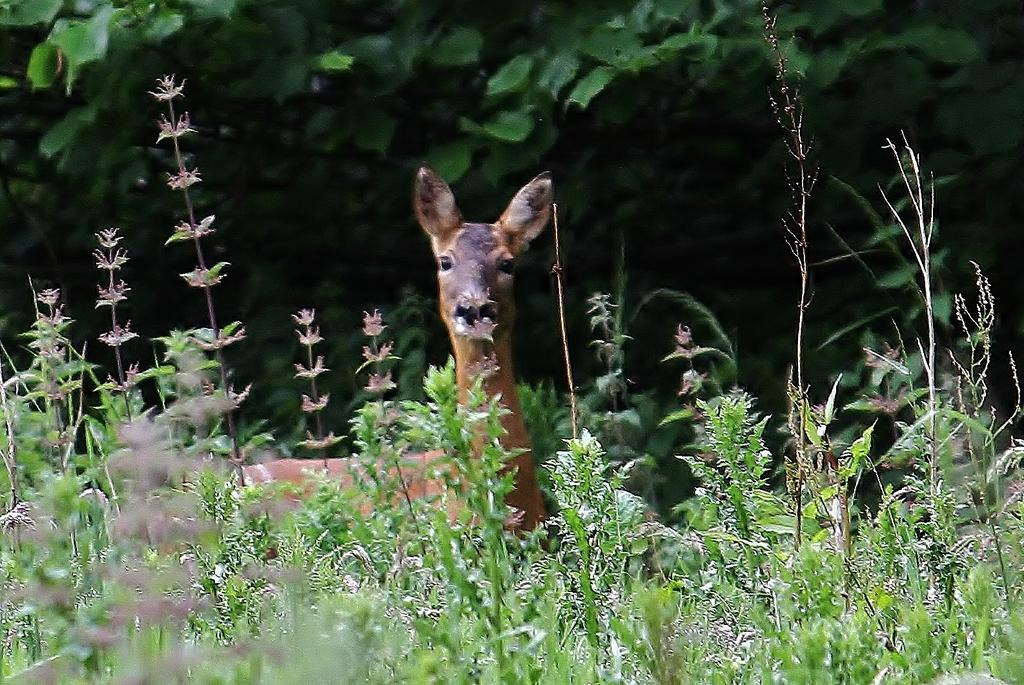What animal can be seen in the picture? There is a deer in the picture. What can be seen in the background of the picture? There are plants and trees in the background of the picture. What type of string is being used by the deer in the picture? There is no string present in the image, and the deer is not using any string. 